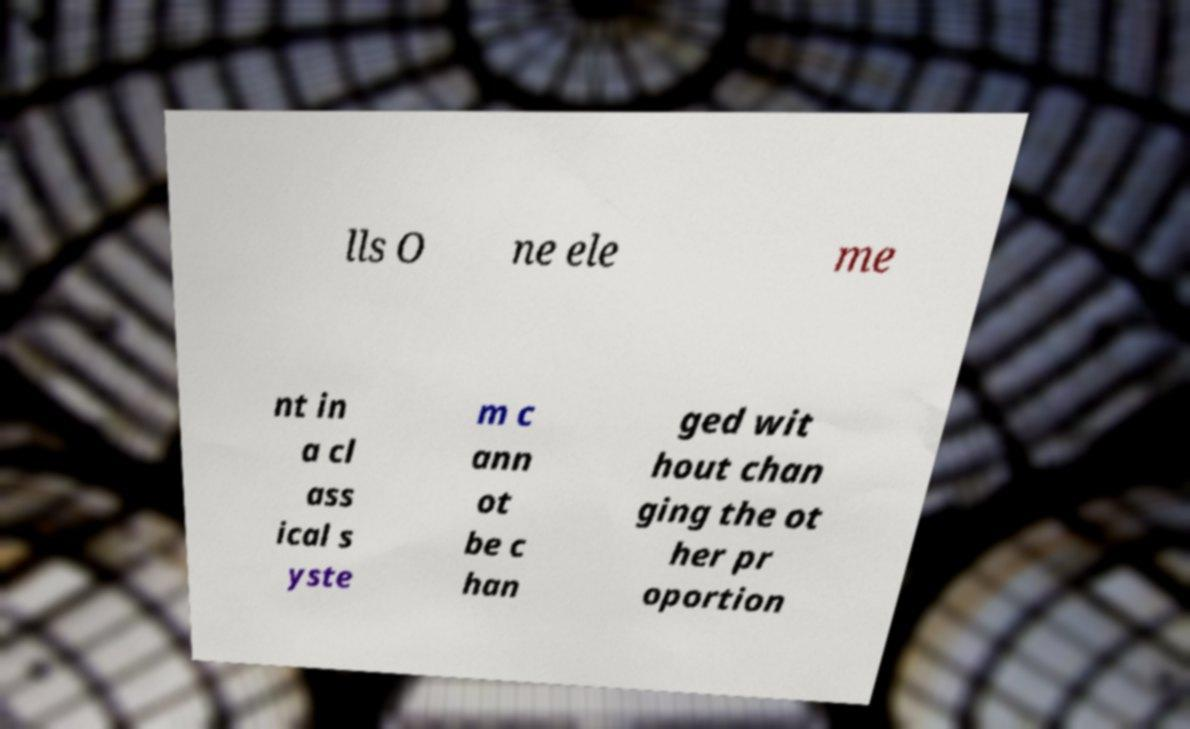Please identify and transcribe the text found in this image. lls O ne ele me nt in a cl ass ical s yste m c ann ot be c han ged wit hout chan ging the ot her pr oportion 